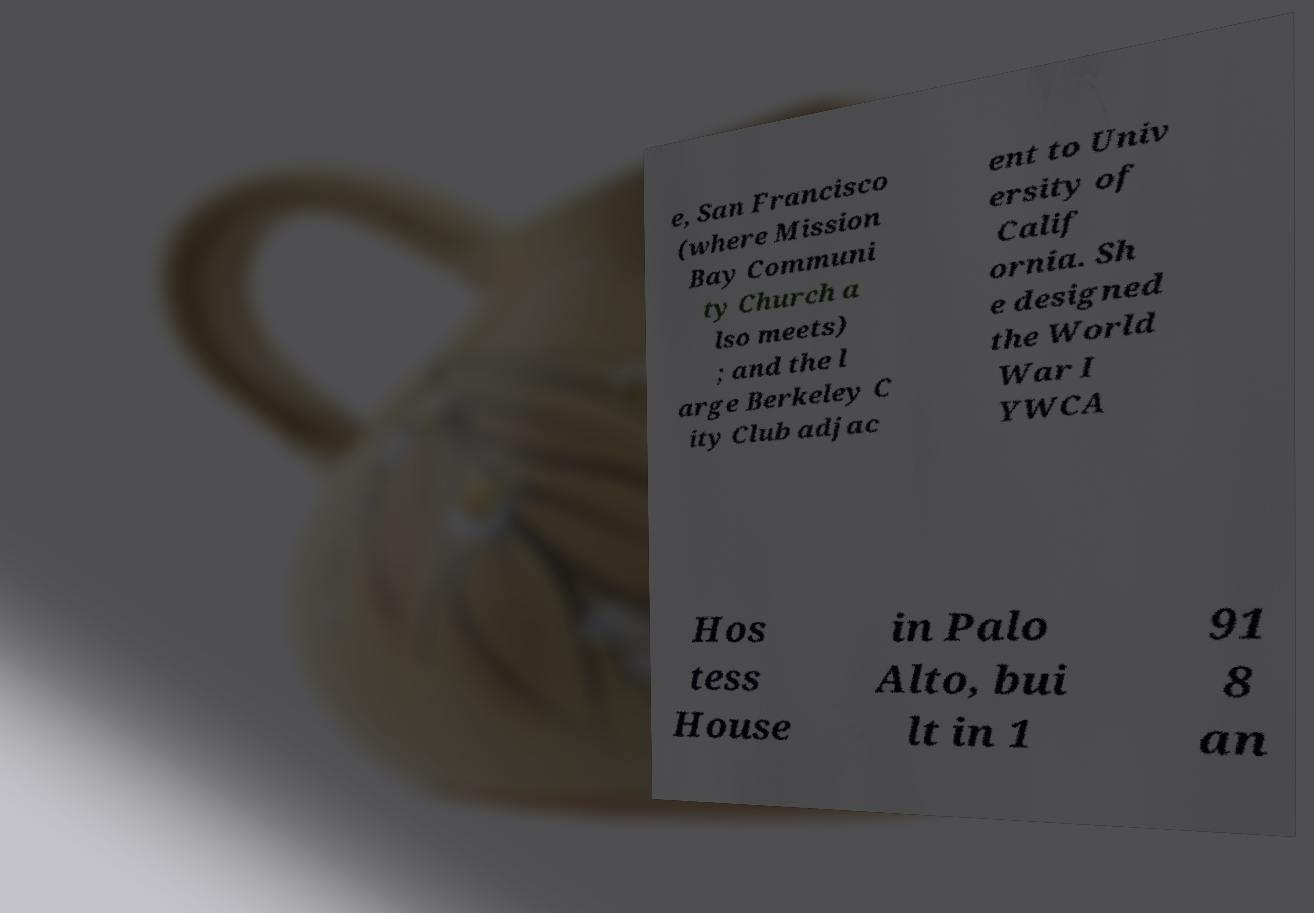Can you read and provide the text displayed in the image?This photo seems to have some interesting text. Can you extract and type it out for me? e, San Francisco (where Mission Bay Communi ty Church a lso meets) ; and the l arge Berkeley C ity Club adjac ent to Univ ersity of Calif ornia. Sh e designed the World War I YWCA Hos tess House in Palo Alto, bui lt in 1 91 8 an 